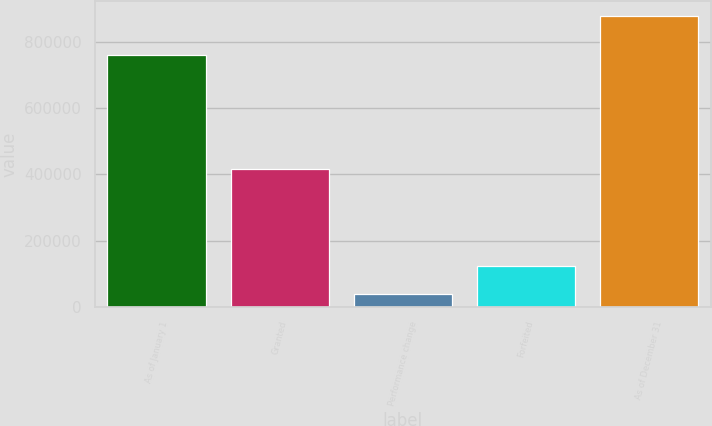<chart> <loc_0><loc_0><loc_500><loc_500><bar_chart><fcel>As of January 1<fcel>Granted<fcel>Performance change<fcel>Forfeited<fcel>As of December 31<nl><fcel>760645<fcel>415024<fcel>39323<fcel>123278<fcel>878872<nl></chart> 